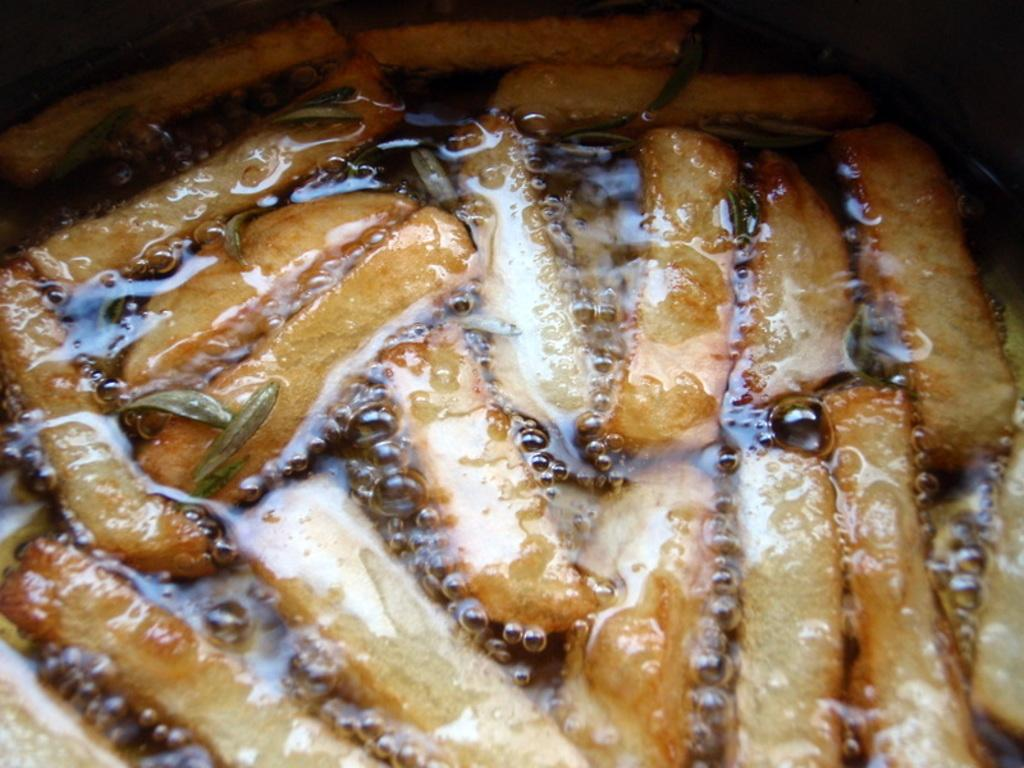What type of food is visible in the image? The specific type of food cannot be determined from the provided facts. What is the substance that appears to be mixed with the food? There is oil in the image. How would you describe the overall appearance of the image? The background of the image is dark. What type of frame is around the food in the image? There is no frame around the food in the image. Is there any indication of pain or discomfort in the image? The provided facts do not mention any pain or discomfort, and the image does not depict any living beings that could experience such emotions. 